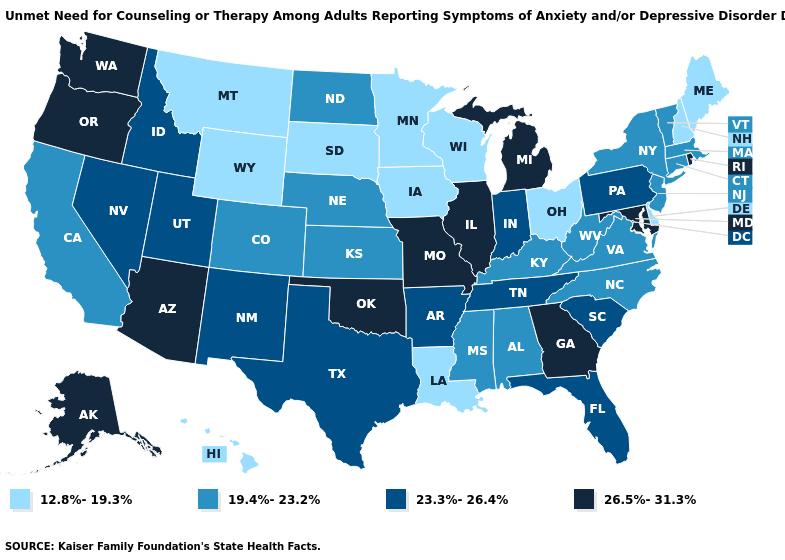What is the highest value in states that border Maryland?
Short answer required. 23.3%-26.4%. Does Florida have a lower value than Tennessee?
Quick response, please. No. How many symbols are there in the legend?
Concise answer only. 4. What is the value of Illinois?
Write a very short answer. 26.5%-31.3%. Does the first symbol in the legend represent the smallest category?
Write a very short answer. Yes. How many symbols are there in the legend?
Short answer required. 4. What is the value of North Dakota?
Be succinct. 19.4%-23.2%. Which states have the lowest value in the MidWest?
Answer briefly. Iowa, Minnesota, Ohio, South Dakota, Wisconsin. Does Minnesota have the highest value in the MidWest?
Give a very brief answer. No. What is the highest value in the South ?
Be succinct. 26.5%-31.3%. What is the value of Kansas?
Short answer required. 19.4%-23.2%. Is the legend a continuous bar?
Short answer required. No. How many symbols are there in the legend?
Be succinct. 4. What is the value of New Mexico?
Write a very short answer. 23.3%-26.4%. Among the states that border Florida , which have the highest value?
Short answer required. Georgia. 